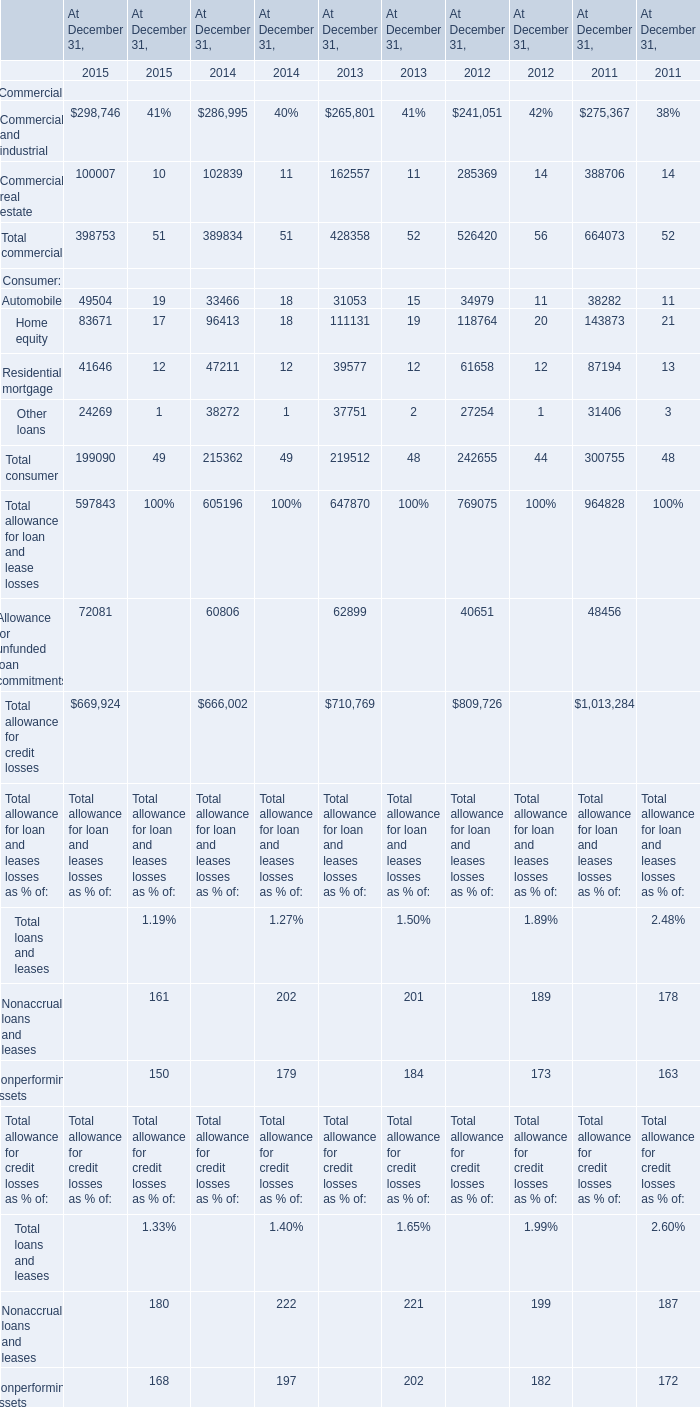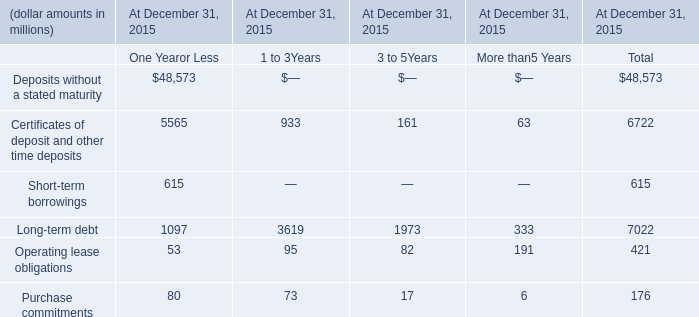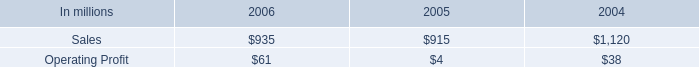in 2005 what percentage of specialty businesses sales are from arizona chemical sales? 
Computations: (692 / 915)
Answer: 0.75628. 